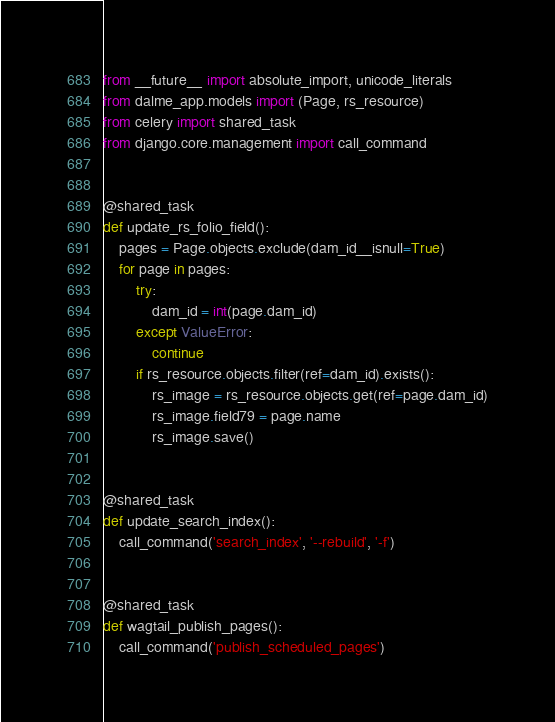Convert code to text. <code><loc_0><loc_0><loc_500><loc_500><_Python_>from __future__ import absolute_import, unicode_literals
from dalme_app.models import (Page, rs_resource)
from celery import shared_task
from django.core.management import call_command


@shared_task
def update_rs_folio_field():
    pages = Page.objects.exclude(dam_id__isnull=True)
    for page in pages:
        try:
            dam_id = int(page.dam_id)
        except ValueError:
            continue
        if rs_resource.objects.filter(ref=dam_id).exists():
            rs_image = rs_resource.objects.get(ref=page.dam_id)
            rs_image.field79 = page.name
            rs_image.save()


@shared_task
def update_search_index():
    call_command('search_index', '--rebuild', '-f')


@shared_task
def wagtail_publish_pages():
    call_command('publish_scheduled_pages')
</code> 